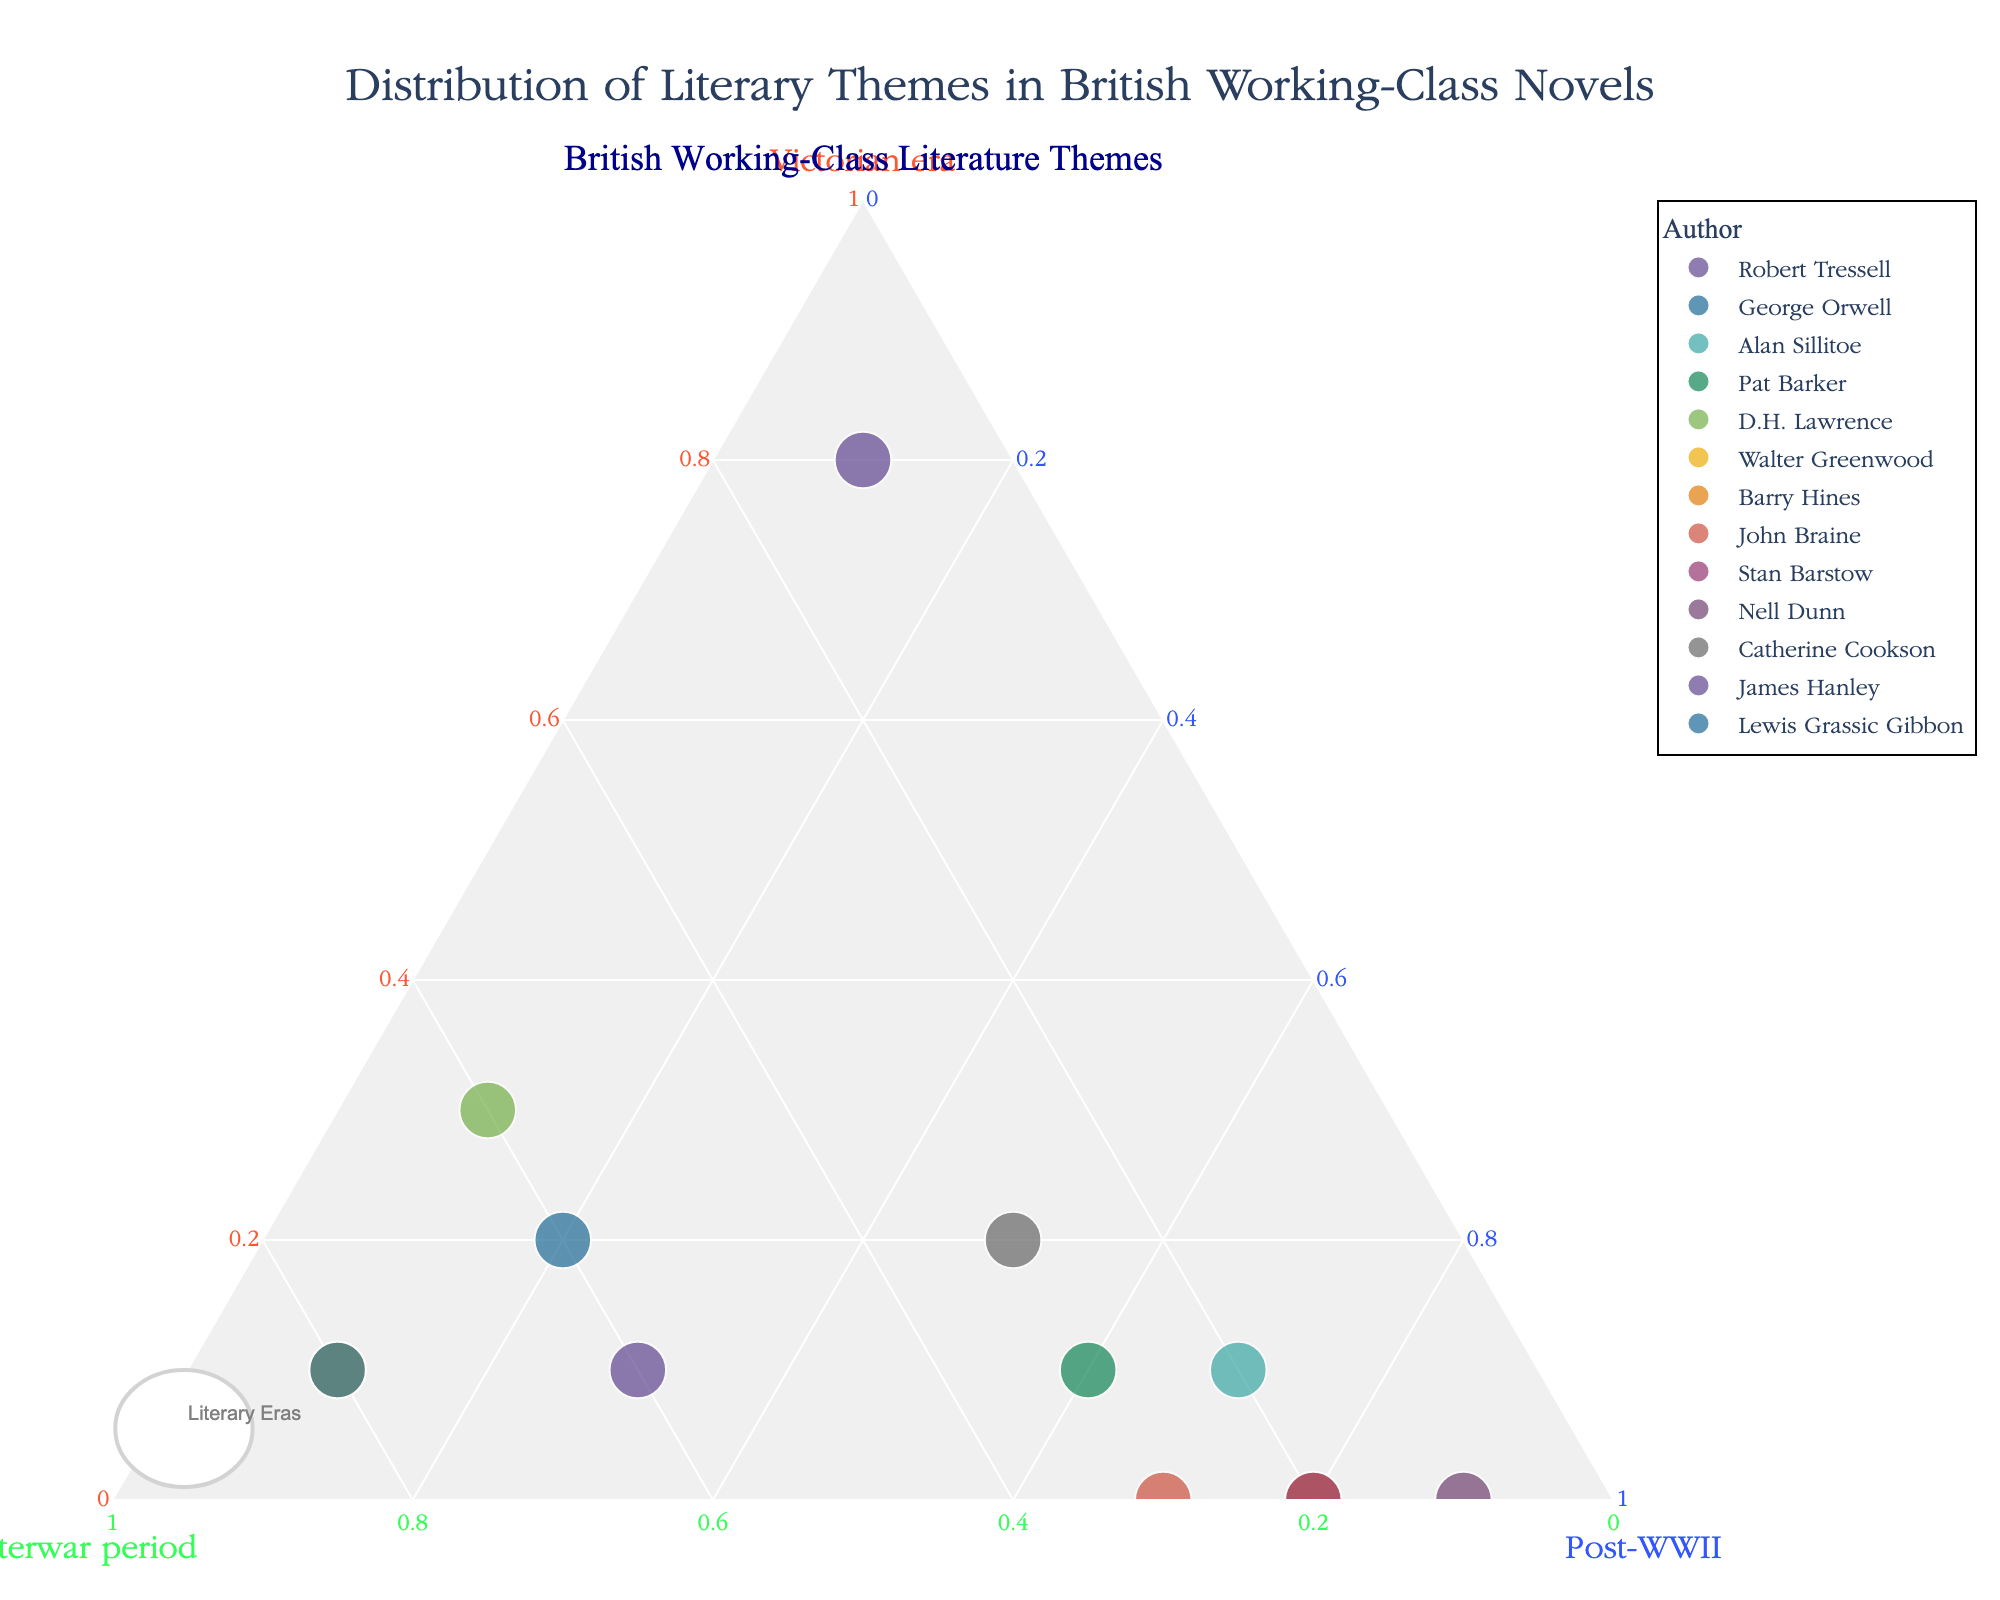- What is the title of the plot? The title of the plot is often displayed at the top of the figure.
Answer: Distribution of Literary Themes in British Working-Class Novels - Which author shows the strongest association with the Victorian era? Look for the point closest to the "Victorian era" vertex.
Answer: Robert Tressell - How many authors have a significant portion of their themes in the Post-WWII era? Count the number of data points located near the "Post-WWII" vertex.
Answer: Five - Which authors have their themes equally distributed between the Interwar period and Post-WWII? Find the points situated approximately along a line connecting the Interwar period and Post-WWII vertices with equal distances.
Answer: George Orwell, Pat Barker - Between D.H. Lawrence and Walter Greenwood, who has a stronger presence in the Interwar period? Compare the distances of both points from the Interwar period vertex.
Answer: Walter Greenwood - What is the average proportion of Post-WWII themes among Alan Sillitoe, John Braine, and Stan Barstow? Sum the Post-WWII values for these authors and then divide by the number of authors. (0.7 + 0.7 + 0.8) / 3 = 0.7333
Answer: 0.7333 - Which author shows the least presence in the Victorian era? Look for the point closest to the opposite axis of the Victorian era vertex.
Answer: Nell Dunn - How do the proportions for D.H. Lawrence compare to those for James Hanley in terms of Interwar period and Post-WWII? Compare the values of Interwar period and Post-WWII for both authors. James Hanley has both higher values for Interwar period and Post-WWII than D.H. Lawrence.
Answer: James Hanley has higher values in both periods - What proportion of literary themes does Barry Hines have in the Victorian era? Check the value corresponding to Barry Hines in the Victorian era axis.
Answer: 0 - Which era is most prominent in the plot overall? Observe the distribution of all data points and determine which vertex most points are nearest to.
Answer: Post-WWII 